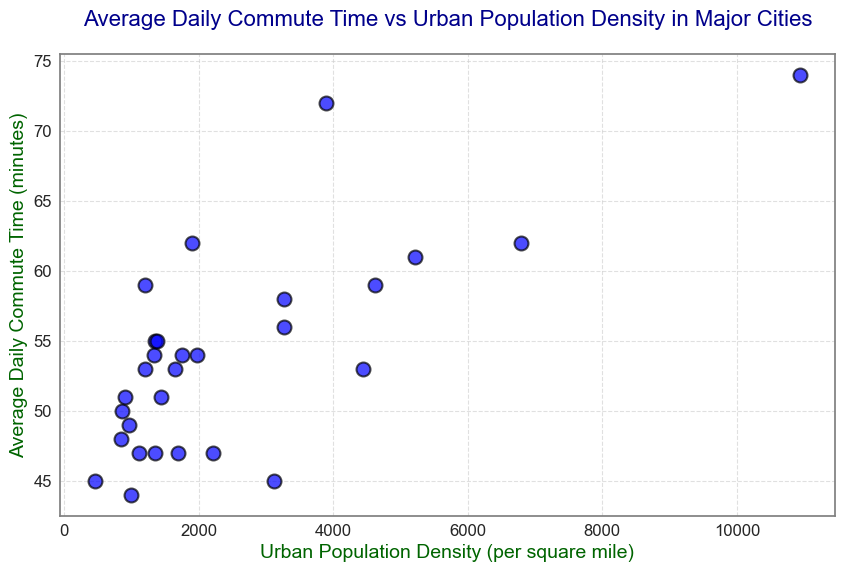What's the city with the highest average daily commute time? The city with the highest point on the y-axis represents the highest average daily commute time. Observing the figure, New York has the highest point on the y-axis.
Answer: New York What is the relationship between urban population density and average daily commute time? The scatter plot shows that as urban population density increases (moving right on the x-axis), average daily commute time generally increases (moving up on the y-axis), indicating a positive relationship.
Answer: Positive relationship Is there a city with a lower urban population density but a higher average daily commute time compared to Chicago? Chicago has an urban population density of 4620 and an average daily commute time of 59 minutes. Checking the plot, Washington D.C. has a lower urban population density of 3901 but a higher average daily commute time of 72 minutes.
Answer: Washington D.C How do the average daily commute times of New York and San Francisco compare? By comparing their respective positions on the scatter plot, New York is higher on the y-axis than San Francisco, indicating a longer average daily commute time for New York.
Answer: New York > San Francisco Find the city with the smallest average daily commute time and provide its urban population density. The city with the smallest point on the y-axis represents the lowest average daily commute time. Observing the figure, Oklahoma City has the smallest y-axis value with an urban population density of 991.
Answer: Oklahoma City, 991 